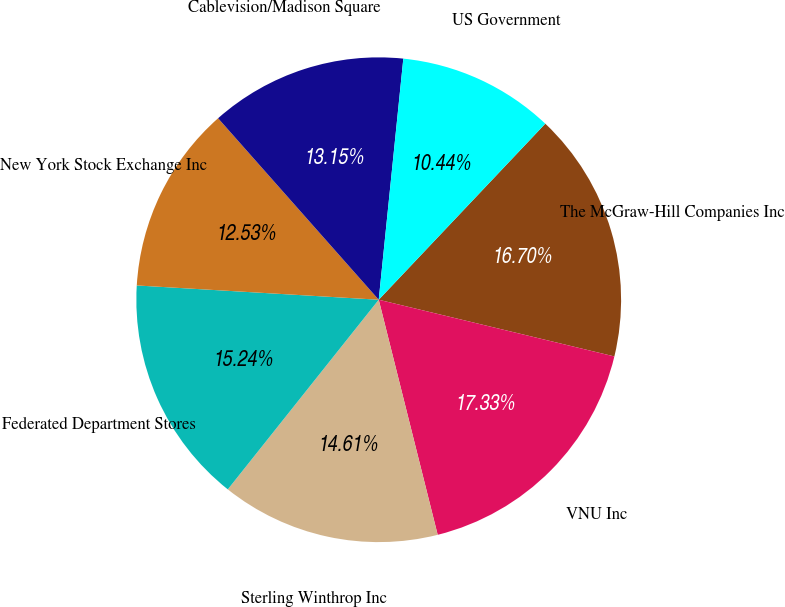Convert chart to OTSL. <chart><loc_0><loc_0><loc_500><loc_500><pie_chart><fcel>The McGraw-Hill Companies Inc<fcel>VNU Inc<fcel>Sterling Winthrop Inc<fcel>Federated Department Stores<fcel>New York Stock Exchange Inc<fcel>Cablevision/Madison Square<fcel>US Government<nl><fcel>16.7%<fcel>17.33%<fcel>14.61%<fcel>15.24%<fcel>12.53%<fcel>13.15%<fcel>10.44%<nl></chart> 